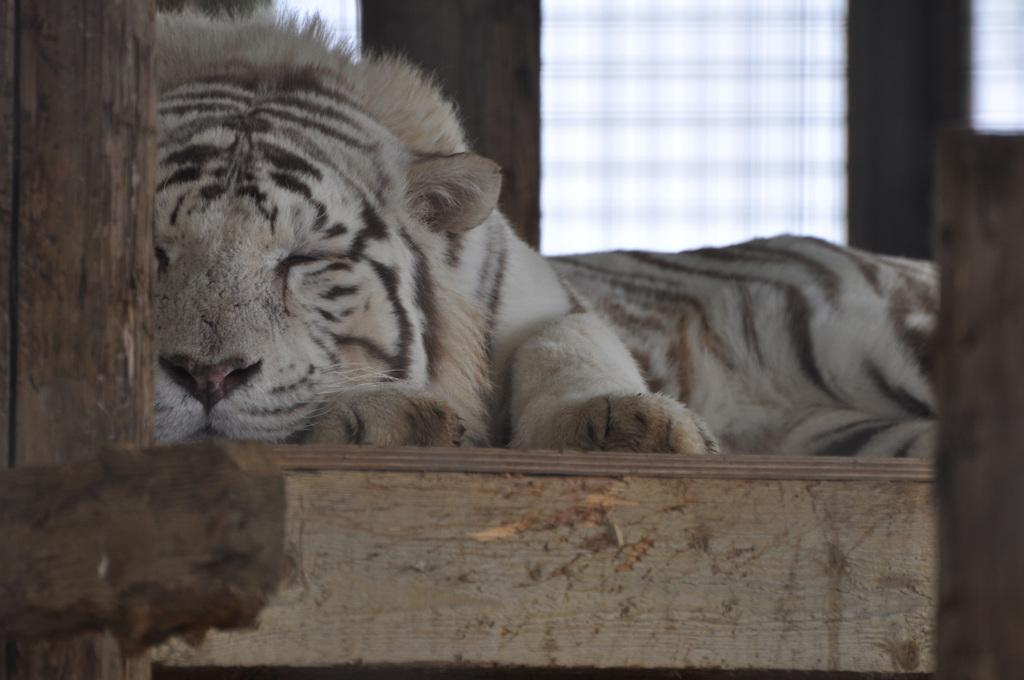What animal can be seen in the picture? There is a tiger in the picture. What is the tiger doing in the picture? The tiger is laying on the floor. What object is in front of the tiger? There is a wooden stick in front of the tiger. What can be seen in the background of the picture? There is a window in the background of the picture. Reasoning: Let' Let's think step by step in order to produce the conversation. We start by identifying the main subject in the image, which is the tiger. Then, we describe the tiger's position and posture, as well as the presence of the wooden stick. Finally, we mention the window in the background, which provides context for the setting. Absurd Question/Answer: What type of tooth is visible in the picture? There is no tooth visible in the picture; it features a tiger laying on the floor with a wooden stick in front of it. What kind of engine can be seen powering the tiger's movements in the picture? There is no engine present in the picture, as tigers are living animals and not machines. 